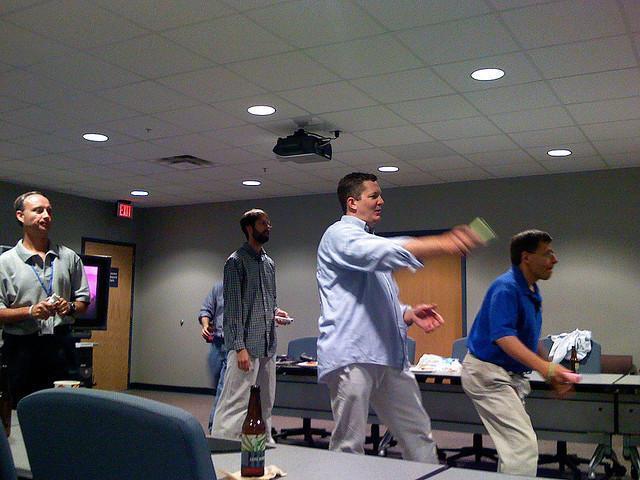How many people are visible?
Give a very brief answer. 5. 